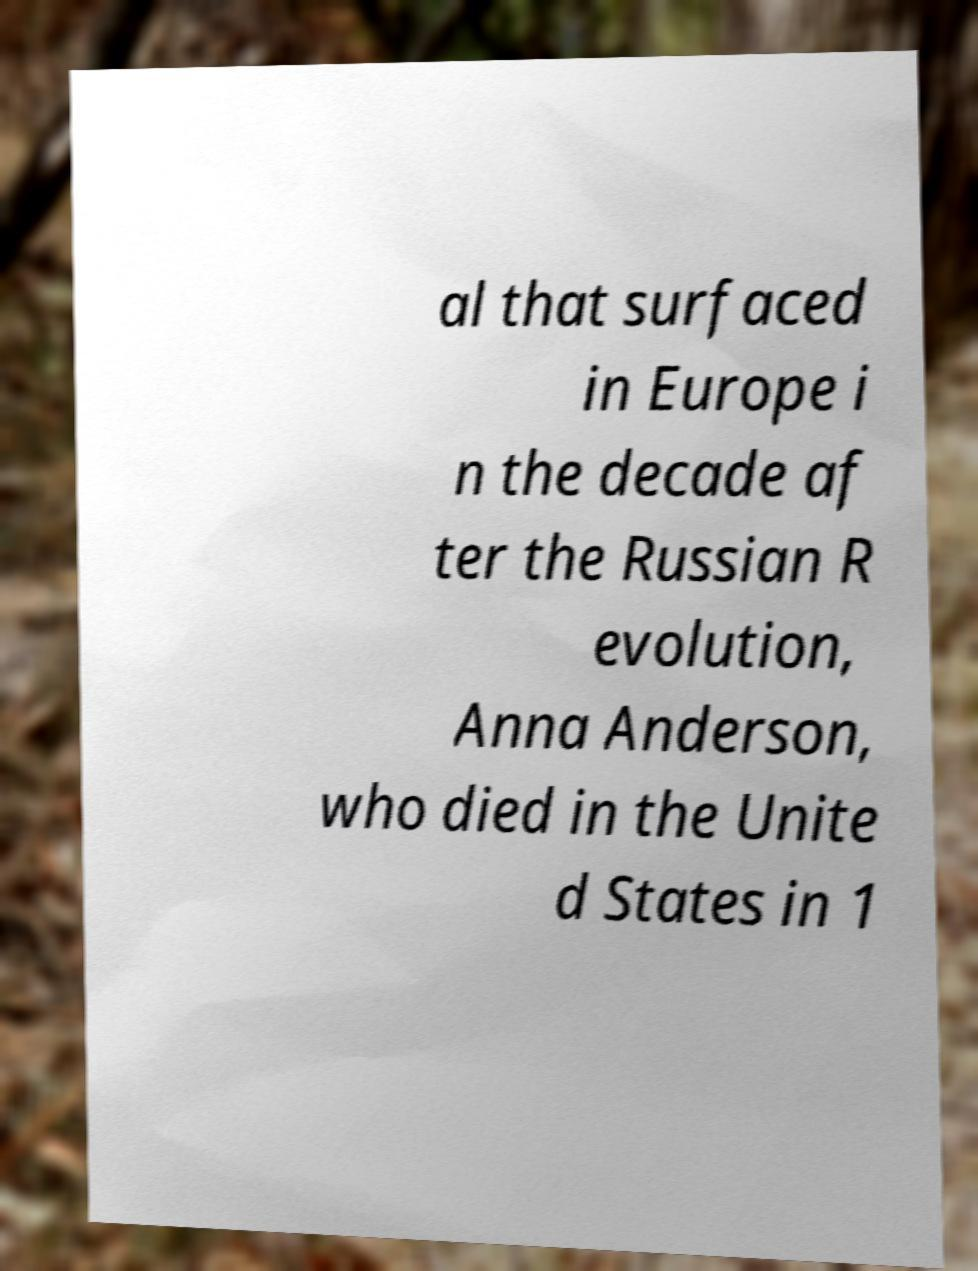Please read and relay the text visible in this image. What does it say? al that surfaced in Europe i n the decade af ter the Russian R evolution, Anna Anderson, who died in the Unite d States in 1 